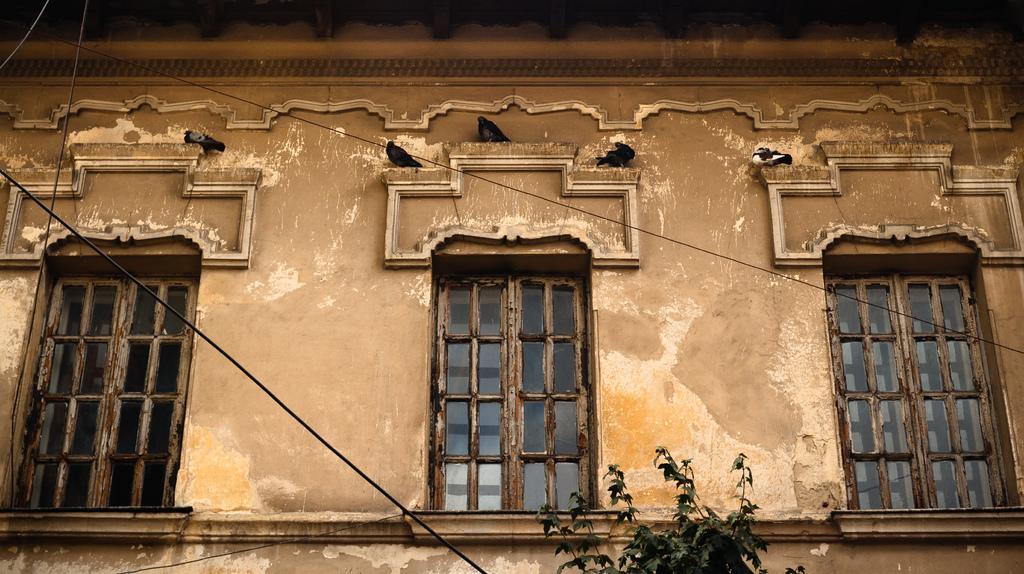Please provide a concise description of this image. In this image there is one building and windows, at the bottom there is a plant and wire and also i can see some birds. 